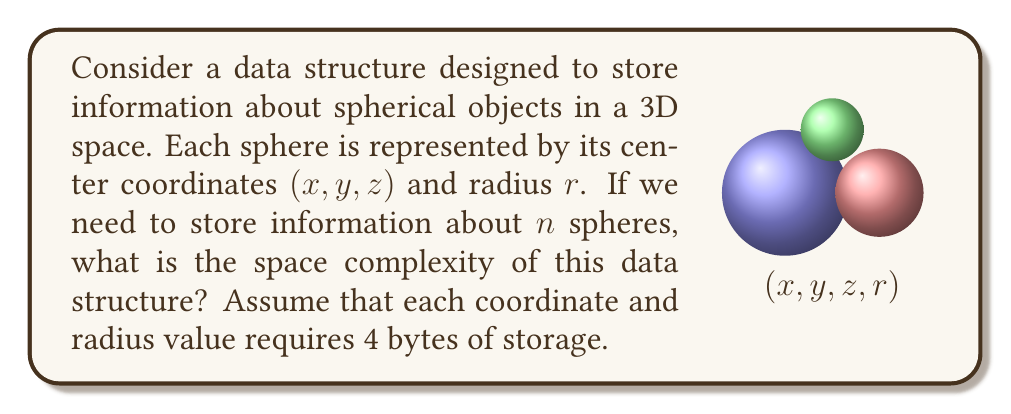Provide a solution to this math problem. Let's approach this step-by-step:

1) For each sphere, we need to store 4 pieces of information:
   - $x$ coordinate (4 bytes)
   - $y$ coordinate (4 bytes)
   - $z$ coordinate (4 bytes)
   - radius $r$ (4 bytes)

2) Total storage for one sphere:
   $$ 4 + 4 + 4 + 4 = 16 \text{ bytes} $$

3) For $n$ spheres, the total storage required would be:
   $$ n \times 16 \text{ bytes} $$

4) In big O notation, we express this as $O(n)$, because the space required grows linearly with the number of spheres.

5) Note that we don't include the constant factor (16) in the big O notation, as it doesn't affect the overall growth rate of the space complexity.

6) This data structure is efficient for storing non-pointed objects (spheres) as it avoids any sharp edges or points, which aligns with the given persona's fear of pointed objects.
Answer: $O(n)$ 